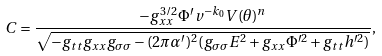<formula> <loc_0><loc_0><loc_500><loc_500>C = \frac { - g _ { x x } ^ { 3 / 2 } \Phi ^ { \prime } v ^ { - k _ { 0 } } V ( \theta ) ^ { n } } { \sqrt { - g _ { t t } g _ { x x } g _ { \sigma \sigma } - ( 2 \pi \alpha ^ { \prime } ) ^ { 2 } ( g _ { \sigma \sigma } E ^ { 2 } + g _ { x x } \Phi ^ { \prime 2 } + g _ { t t } h ^ { \prime 2 } ) } } ,</formula> 